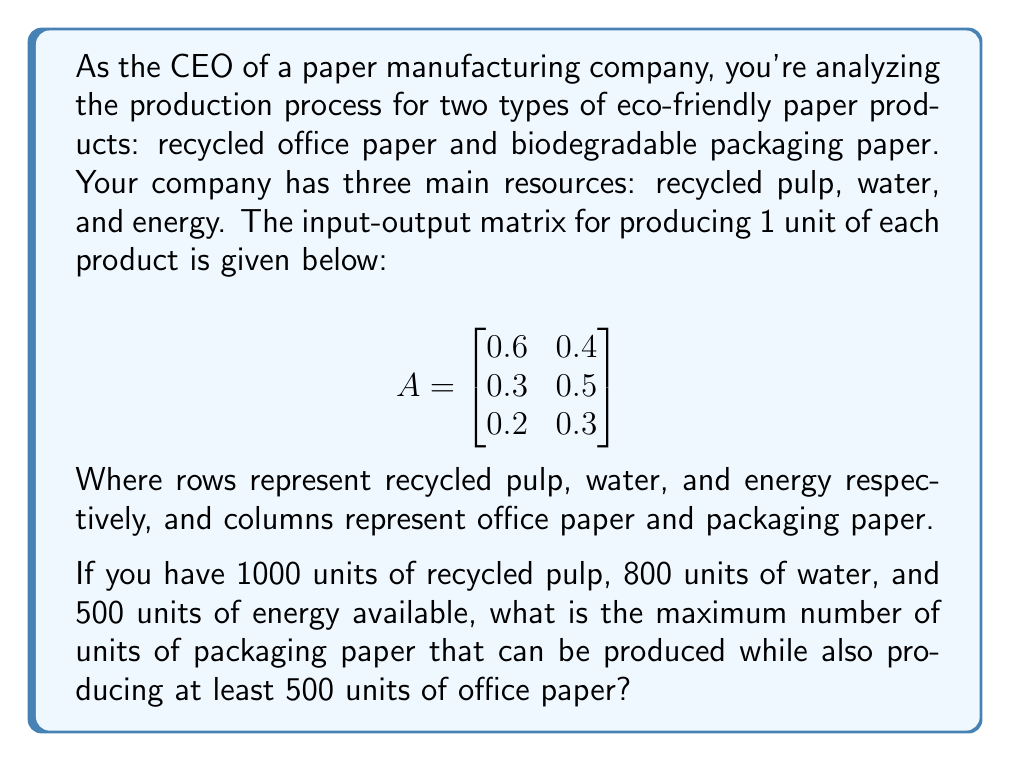Can you answer this question? Let's approach this step-by-step:

1) Let $x$ be the number of units of office paper and $y$ be the number of units of packaging paper.

2) We need to set up inequalities based on our resource constraints:

   Recycled pulp: $0.6x + 0.4y \leq 1000$
   Water: $0.3x + 0.5y \leq 800$
   Energy: $0.2x + 0.3y \leq 500$

3) We also have the constraint that we need at least 500 units of office paper:

   $x \geq 500$

4) Our objective is to maximize $y$, subject to these constraints.

5) Let's start by setting $x = 500$ (the minimum required) and solve for the maximum $y$ in each inequality:

   From recycled pulp: $0.6(500) + 0.4y \leq 1000$
                       $300 + 0.4y \leq 1000$
                       $0.4y \leq 700$
                       $y \leq 1750$

   From water: $0.3(500) + 0.5y \leq 800$
               $150 + 0.5y \leq 800$
               $0.5y \leq 650$
               $y \leq 1300$

   From energy: $0.2(500) + 0.3y \leq 500$
                $100 + 0.3y \leq 500$
                $0.3y \leq 400$
                $y \leq 1333.33$

6) The maximum value for $y$ is the smallest of these results, which is 1300.

Therefore, the maximum number of units of packaging paper that can be produced while also producing 500 units of office paper is 1300 units.
Answer: 1300 units 